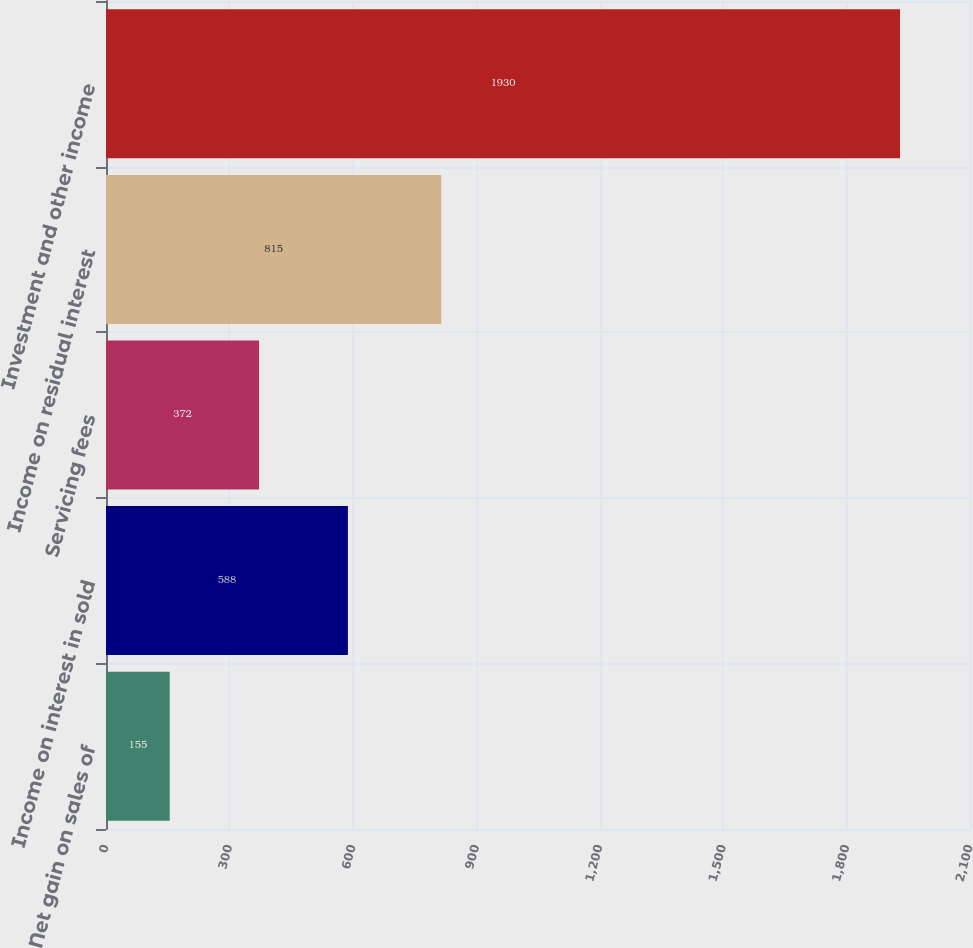<chart> <loc_0><loc_0><loc_500><loc_500><bar_chart><fcel>Net gain on sales of<fcel>Income on interest in sold<fcel>Servicing fees<fcel>Income on residual interest<fcel>Investment and other income<nl><fcel>155<fcel>588<fcel>372<fcel>815<fcel>1930<nl></chart> 